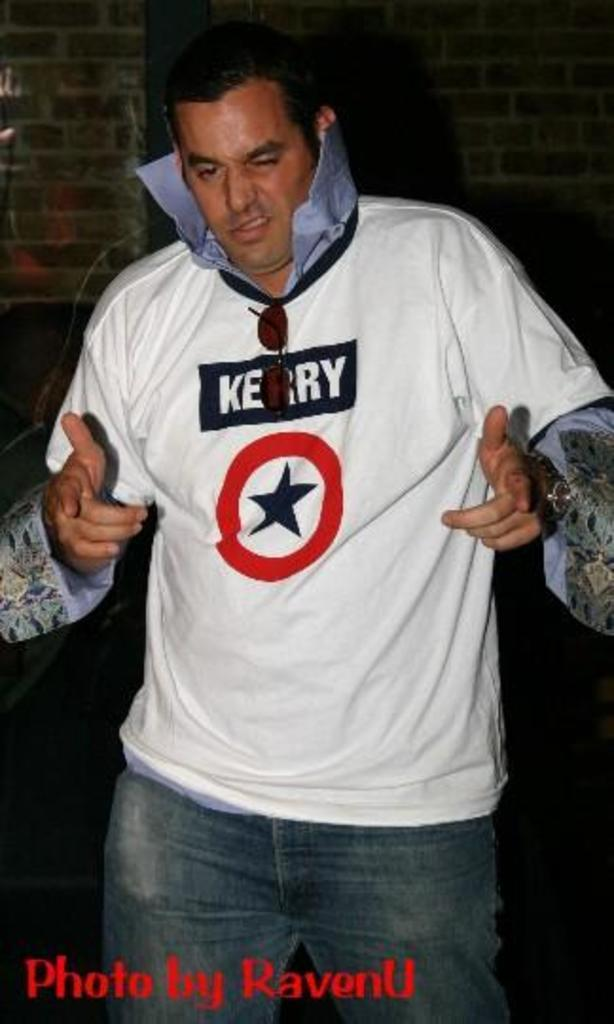<image>
Write a terse but informative summary of the picture. A man in a Kerry shirt with a logo that has a star in a circle 